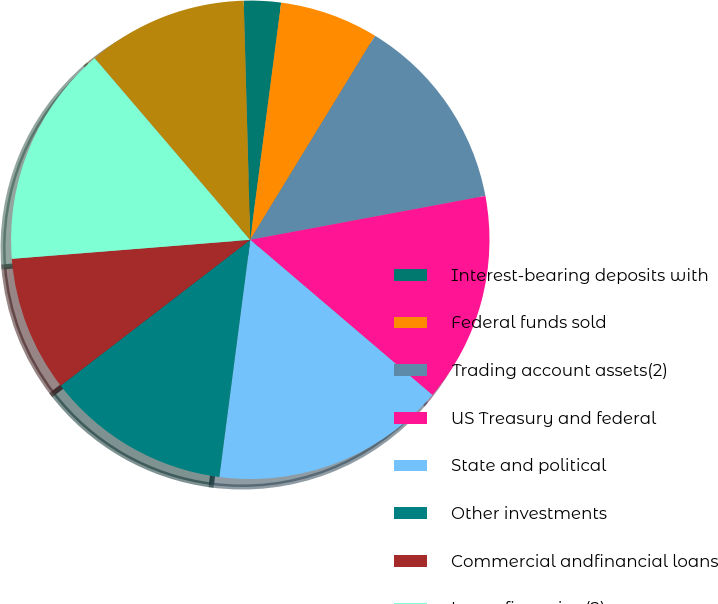<chart> <loc_0><loc_0><loc_500><loc_500><pie_chart><fcel>Interest-bearing deposits with<fcel>Federal funds sold<fcel>Trading account assets(2)<fcel>US Treasury and federal<fcel>State and political<fcel>Other investments<fcel>Commercial andfinancial loans<fcel>Lease financing(2)<fcel>Total interest-earning<nl><fcel>2.5%<fcel>6.67%<fcel>13.33%<fcel>14.17%<fcel>15.83%<fcel>12.5%<fcel>9.17%<fcel>15.0%<fcel>10.83%<nl></chart> 